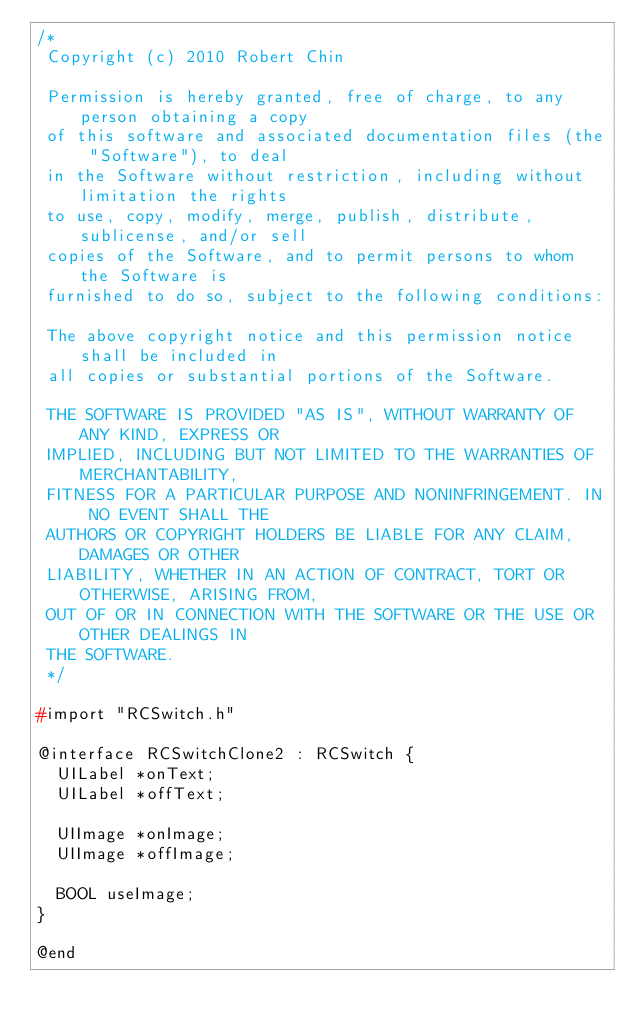Convert code to text. <code><loc_0><loc_0><loc_500><loc_500><_C_>/*
 Copyright (c) 2010 Robert Chin
 
 Permission is hereby granted, free of charge, to any person obtaining a copy
 of this software and associated documentation files (the "Software"), to deal
 in the Software without restriction, including without limitation the rights
 to use, copy, modify, merge, publish, distribute, sublicense, and/or sell
 copies of the Software, and to permit persons to whom the Software is
 furnished to do so, subject to the following conditions:
 
 The above copyright notice and this permission notice shall be included in
 all copies or substantial portions of the Software.
 
 THE SOFTWARE IS PROVIDED "AS IS", WITHOUT WARRANTY OF ANY KIND, EXPRESS OR
 IMPLIED, INCLUDING BUT NOT LIMITED TO THE WARRANTIES OF MERCHANTABILITY,
 FITNESS FOR A PARTICULAR PURPOSE AND NONINFRINGEMENT. IN NO EVENT SHALL THE
 AUTHORS OR COPYRIGHT HOLDERS BE LIABLE FOR ANY CLAIM, DAMAGES OR OTHER
 LIABILITY, WHETHER IN AN ACTION OF CONTRACT, TORT OR OTHERWISE, ARISING FROM,
 OUT OF OR IN CONNECTION WITH THE SOFTWARE OR THE USE OR OTHER DEALINGS IN
 THE SOFTWARE.
 */

#import "RCSwitch.h"

@interface RCSwitchClone2 : RCSwitch {
	UILabel *onText;
	UILabel *offText;
	
	UIImage *onImage;
	UIImage *offImage;
	
	BOOL useImage;
}

@end</code> 